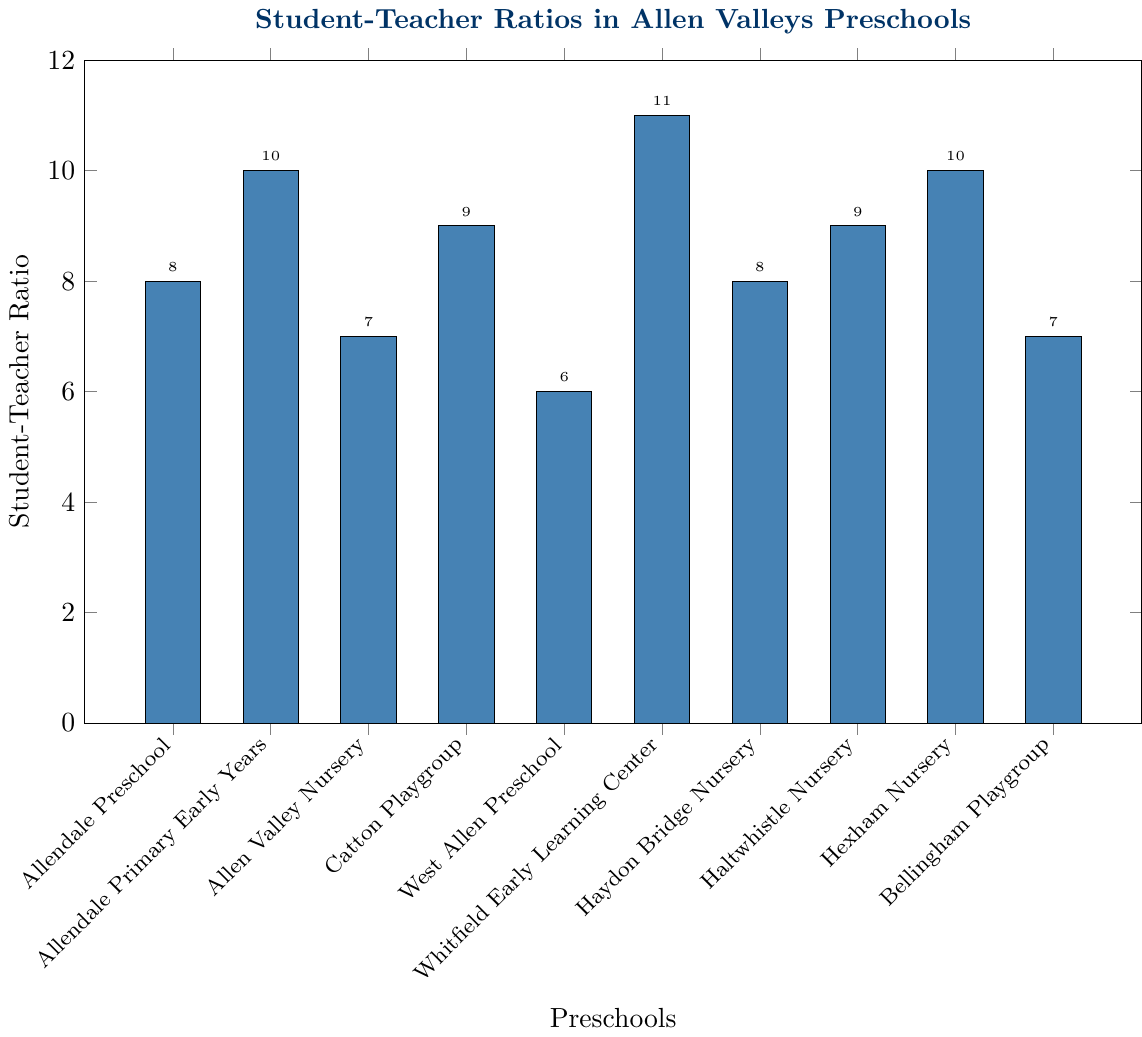Which preschool has the highest student-teacher ratio? By looking at the height of the bars in the chart, Whitfield Early Learning Center has the highest bar, which indicates it has the highest student-teacher ratio.
Answer: Whitfield Early Learning Center What is the difference in the student-teacher ratio between Allendale Preschool and West Allen Preschool? The student-teacher ratio of Allendale Preschool is 8:1, and for West Allen Preschool, it is 6:1. The difference can be calculated by subtracting the smaller ratio from the larger ratio: 8 - 6 = 2.
Answer: 2 Which preschools have a student-teacher ratio lower than Allendale Preschool? By comparing the heights of the bars, Allen Valley Nursery (7:1), West Allen Preschool (6:1), and Bellingham Playgroup (7:1) have lower student-teacher ratios than Allendale Preschool (8:1).
Answer: Allen Valley Nursery, West Allen Preschool, Bellingham Playgroup How many preschools have a student-teacher ratio of exactly 9:1? Looking at the chart, Catton Playgroup and Haltwhistle Nursery both have a student-teacher ratio of 9:1. By counting the number of such bars, we get the answer.
Answer: 2 What is the average student-teacher ratio of all the preschools listed? To find the average, we sum all the student-teacher ratios (8 + 10 + 7 + 9 + 6 + 11 + 8 + 9 + 10 + 7 = 85) and then divide by the number of preschools (10). The average ratio is 85 / 10 = 8.5.
Answer: 8.5 If the ideal student-teacher ratio is considered to be 8:1, which preschools meet this ideal ratio? By looking at the chart, Allendale Preschool and Haydon Bridge Nursery each have a student-teacher ratio of 8:1.
Answer: Allendale Preschool, Haydon Bridge Nursery Which preschool has the same student-teacher ratio as Allendale Preschool? By comparing the heights of the bars, Haydon Bridge Nursery has the same student-teacher ratio (8:1) as Allendale Preschool.
Answer: Haydon Bridge Nursery What is the total sum of student-teacher ratios for preschools with a ratio less than 9:1? Adding the ratios of preschools with a student-teacher ratio of less than 9:1: Allendale Preschool (8), Allen Valley Nursery (7), West Allen Preschool (6), Haydon Bridge Nursery (8), Bellingham Playgroup (7). The total sum is 8 + 7 + 6 + 8 + 7 = 36.
Answer: 36 Which preschool has a student-teacher ratio 1 unit higher than Allendale Preschool? By adding 1 to the ratio of Allendale Preschool (8 + 1 = 9) and looking at the chart, Catton Playgroup and Haltwhistle Nursery both have a student-teacher ratio of 9:1.
Answer: Catton Playgroup, Haltwhistle Nursery 